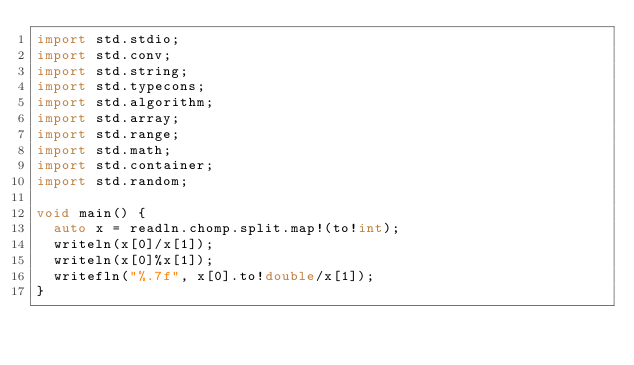<code> <loc_0><loc_0><loc_500><loc_500><_D_>import std.stdio;
import std.conv;
import std.string;
import std.typecons;
import std.algorithm;
import std.array;
import std.range;
import std.math;
import std.container;
import std.random;
      
void main() {
  auto x = readln.chomp.split.map!(to!int);
  writeln(x[0]/x[1]);
  writeln(x[0]%x[1]);
  writefln("%.7f", x[0].to!double/x[1]);
}</code> 